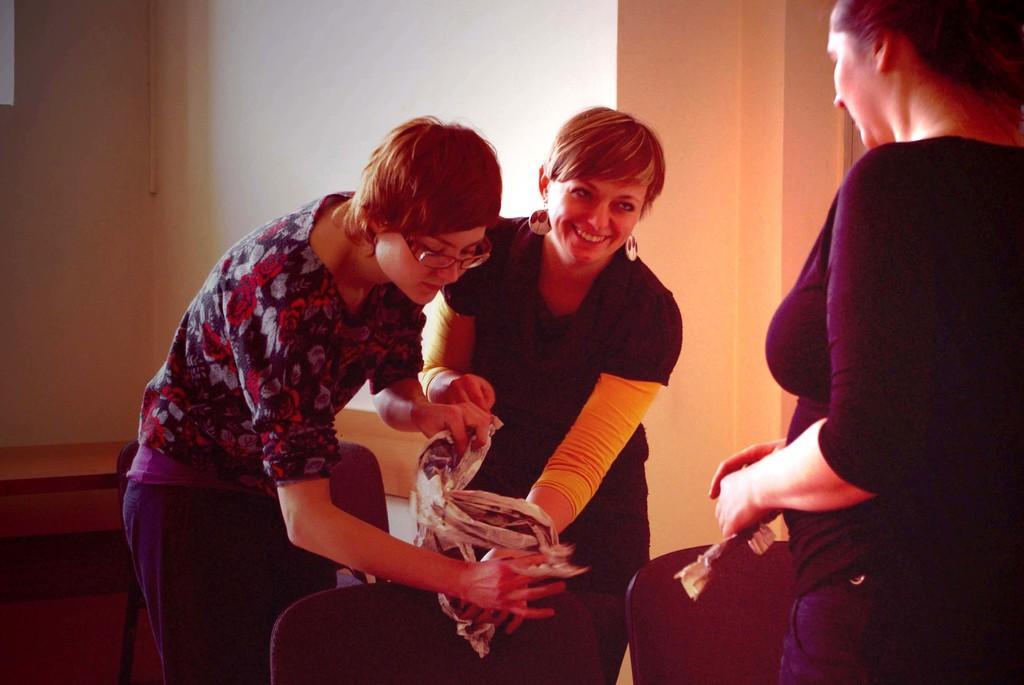In one or two sentences, can you explain what this image depicts? In this image we can see some persons, chairs and other objects. In the background of the image there is a wall and other objects. 